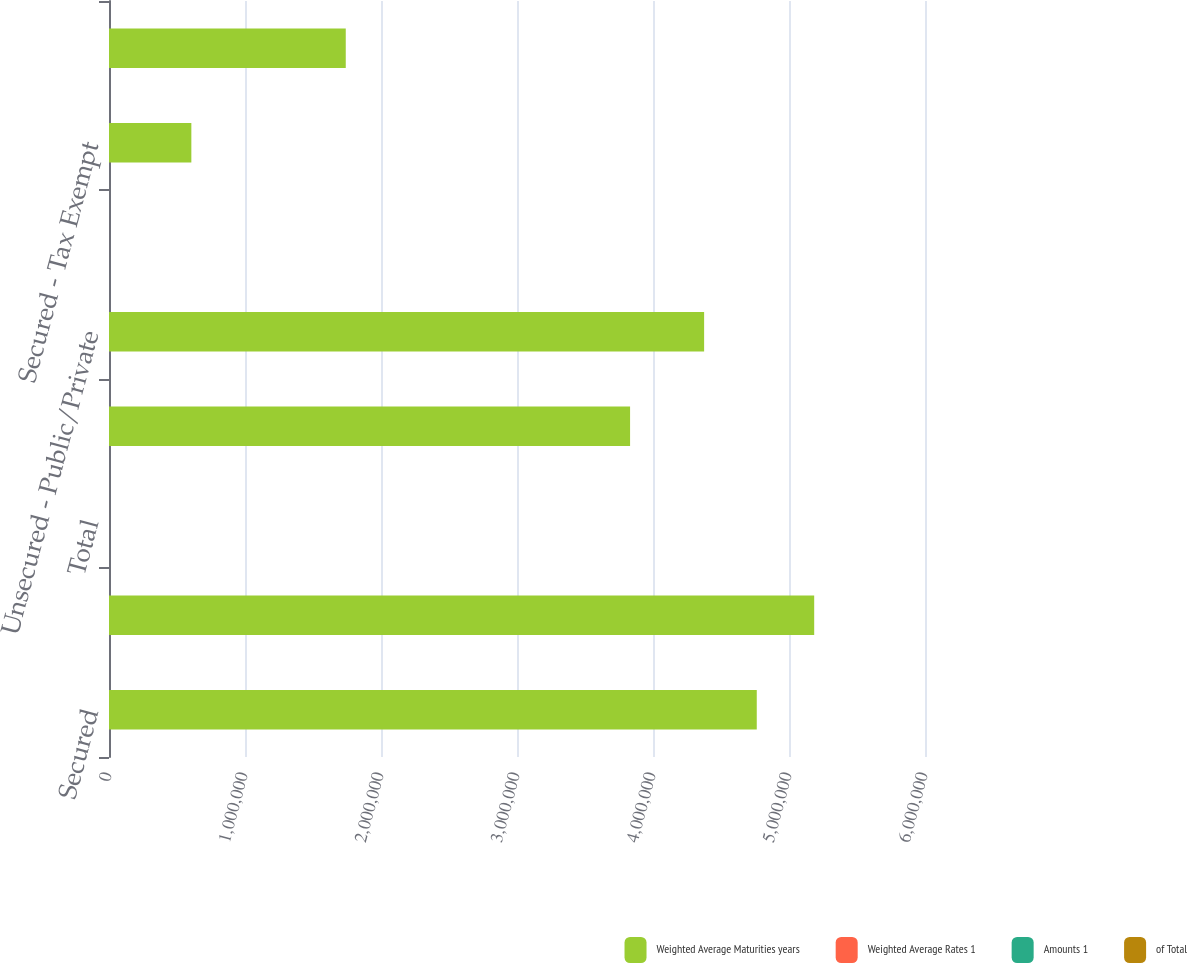Convert chart to OTSL. <chart><loc_0><loc_0><loc_500><loc_500><stacked_bar_chart><ecel><fcel>Secured<fcel>Unsecured<fcel>Total<fcel>Secured - Conventional<fcel>Unsecured - Public/Private<fcel>Fixed Rate Debt<fcel>Secured - Tax Exempt<fcel>Floating Rate Debt<nl><fcel>Weighted Average Maturities years<fcel>4.7629e+06<fcel>5.18518e+06<fcel>7.8<fcel>3.83139e+06<fcel>4.37586e+06<fcel>7.8<fcel>605494<fcel>1.74082e+06<nl><fcel>Weighted Average Rates 1<fcel>47.9<fcel>52.1<fcel>100<fcel>38.5<fcel>44<fcel>82.5<fcel>6.1<fcel>17.5<nl><fcel>Amounts 1<fcel>4.79<fcel>4.96<fcel>4.88<fcel>5.68<fcel>5.78<fcel>5.73<fcel>0.48<fcel>1.39<nl><fcel>of Total<fcel>8.1<fcel>4.5<fcel>6.2<fcel>6.9<fcel>5.1<fcel>5.9<fcel>20.4<fcel>7.5<nl></chart> 